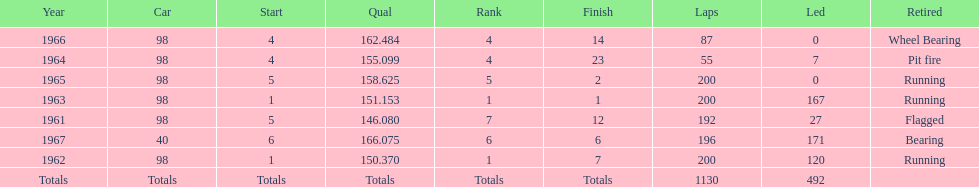In how many instances did he secure a position within the top three? 2. 